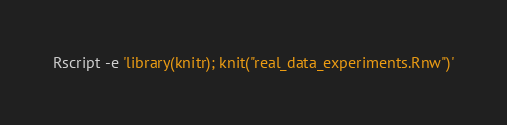<code> <loc_0><loc_0><loc_500><loc_500><_Bash_>
Rscript -e 'library(knitr); knit("real_data_experiments.Rnw")'
</code> 